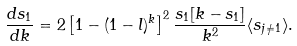Convert formula to latex. <formula><loc_0><loc_0><loc_500><loc_500>\frac { d s _ { 1 } } { d k } = 2 \left [ 1 - ( 1 - l ) ^ { k } \right ] ^ { 2 } \frac { s _ { 1 } [ k - s _ { 1 } ] } { k ^ { 2 } } \langle s _ { j \neq 1 } \rangle .</formula> 